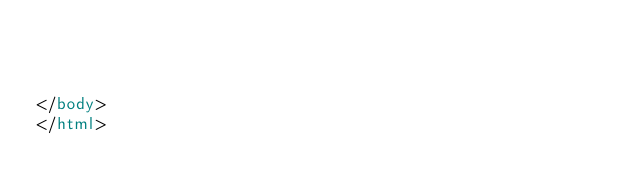<code> <loc_0><loc_0><loc_500><loc_500><_HTML_>		
		
		
</body>
</html></code> 